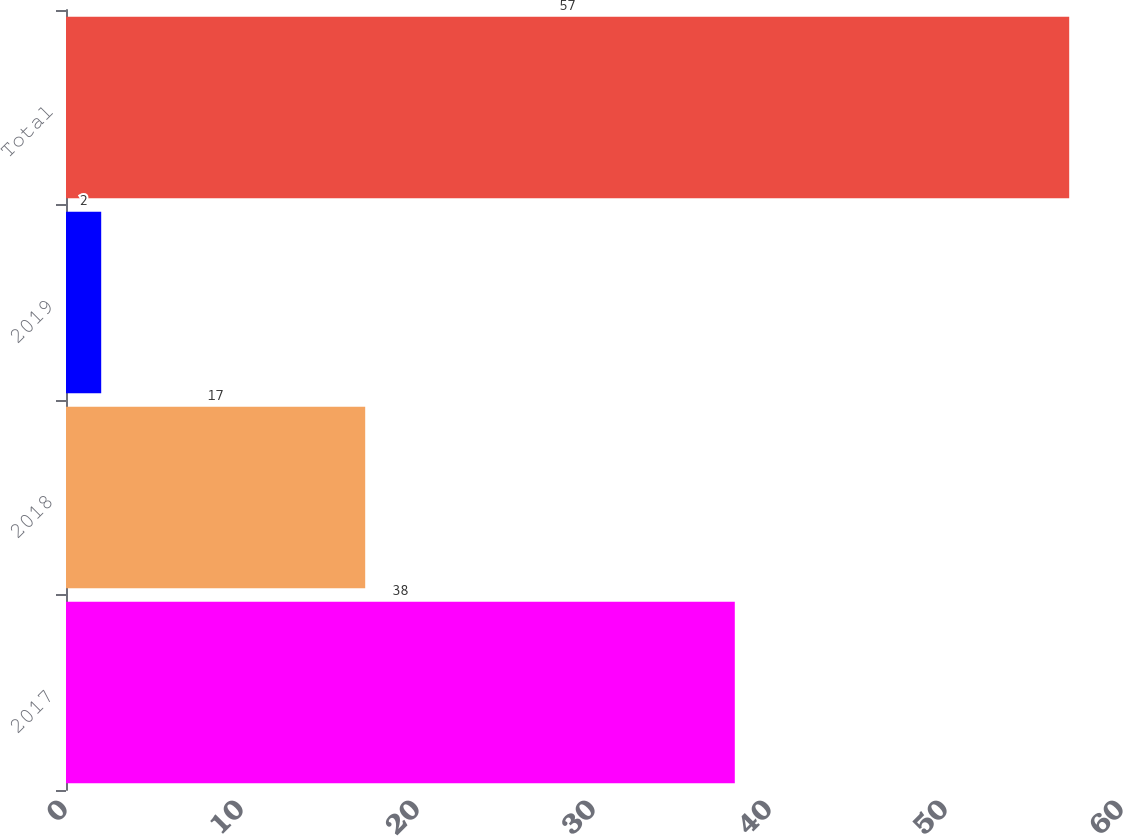Convert chart. <chart><loc_0><loc_0><loc_500><loc_500><bar_chart><fcel>2017<fcel>2018<fcel>2019<fcel>Total<nl><fcel>38<fcel>17<fcel>2<fcel>57<nl></chart> 